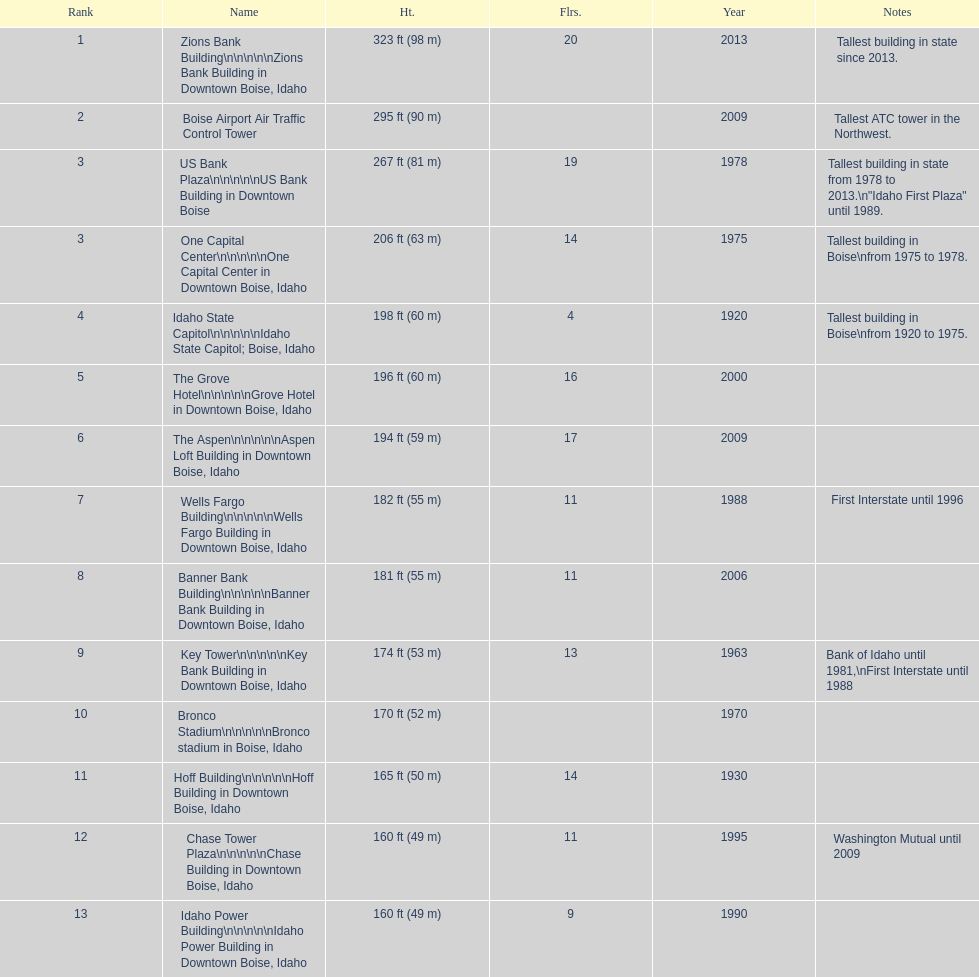Would you mind parsing the complete table? {'header': ['Rank', 'Name', 'Ht.', 'Flrs.', 'Year', 'Notes'], 'rows': [['1', 'Zions Bank Building\\n\\n\\n\\n\\nZions Bank Building in Downtown Boise, Idaho', '323\xa0ft (98\xa0m)', '20', '2013', 'Tallest building in state since 2013.'], ['2', 'Boise Airport Air Traffic Control Tower', '295\xa0ft (90\xa0m)', '', '2009', 'Tallest ATC tower in the Northwest.'], ['3', 'US Bank Plaza\\n\\n\\n\\n\\nUS Bank Building in Downtown Boise', '267\xa0ft (81\xa0m)', '19', '1978', 'Tallest building in state from 1978 to 2013.\\n"Idaho First Plaza" until 1989.'], ['3', 'One Capital Center\\n\\n\\n\\n\\nOne Capital Center in Downtown Boise, Idaho', '206\xa0ft (63\xa0m)', '14', '1975', 'Tallest building in Boise\\nfrom 1975 to 1978.'], ['4', 'Idaho State Capitol\\n\\n\\n\\n\\nIdaho State Capitol; Boise, Idaho', '198\xa0ft (60\xa0m)', '4', '1920', 'Tallest building in Boise\\nfrom 1920 to 1975.'], ['5', 'The Grove Hotel\\n\\n\\n\\n\\nGrove Hotel in Downtown Boise, Idaho', '196\xa0ft (60\xa0m)', '16', '2000', ''], ['6', 'The Aspen\\n\\n\\n\\n\\nAspen Loft Building in Downtown Boise, Idaho', '194\xa0ft (59\xa0m)', '17', '2009', ''], ['7', 'Wells Fargo Building\\n\\n\\n\\n\\nWells Fargo Building in Downtown Boise, Idaho', '182\xa0ft (55\xa0m)', '11', '1988', 'First Interstate until 1996'], ['8', 'Banner Bank Building\\n\\n\\n\\n\\nBanner Bank Building in Downtown Boise, Idaho', '181\xa0ft (55\xa0m)', '11', '2006', ''], ['9', 'Key Tower\\n\\n\\n\\n\\nKey Bank Building in Downtown Boise, Idaho', '174\xa0ft (53\xa0m)', '13', '1963', 'Bank of Idaho until 1981,\\nFirst Interstate until 1988'], ['10', 'Bronco Stadium\\n\\n\\n\\n\\nBronco stadium in Boise, Idaho', '170\xa0ft (52\xa0m)', '', '1970', ''], ['11', 'Hoff Building\\n\\n\\n\\n\\nHoff Building in Downtown Boise, Idaho', '165\xa0ft (50\xa0m)', '14', '1930', ''], ['12', 'Chase Tower Plaza\\n\\n\\n\\n\\nChase Building in Downtown Boise, Idaho', '160\xa0ft (49\xa0m)', '11', '1995', 'Washington Mutual until 2009'], ['13', 'Idaho Power Building\\n\\n\\n\\n\\nIdaho Power Building in Downtown Boise, Idaho', '160\xa0ft (49\xa0m)', '9', '1990', '']]} Which building has the most floors according to this chart? Zions Bank Building. 